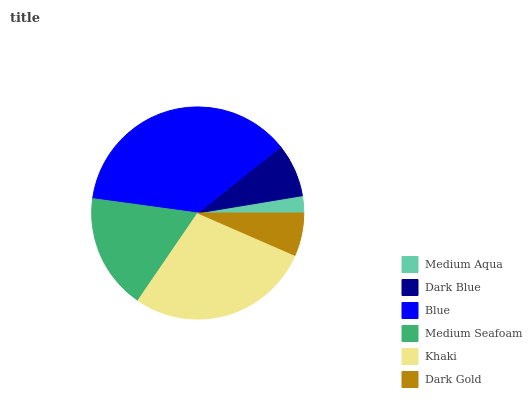Is Medium Aqua the minimum?
Answer yes or no. Yes. Is Blue the maximum?
Answer yes or no. Yes. Is Dark Blue the minimum?
Answer yes or no. No. Is Dark Blue the maximum?
Answer yes or no. No. Is Dark Blue greater than Medium Aqua?
Answer yes or no. Yes. Is Medium Aqua less than Dark Blue?
Answer yes or no. Yes. Is Medium Aqua greater than Dark Blue?
Answer yes or no. No. Is Dark Blue less than Medium Aqua?
Answer yes or no. No. Is Medium Seafoam the high median?
Answer yes or no. Yes. Is Dark Blue the low median?
Answer yes or no. Yes. Is Blue the high median?
Answer yes or no. No. Is Blue the low median?
Answer yes or no. No. 